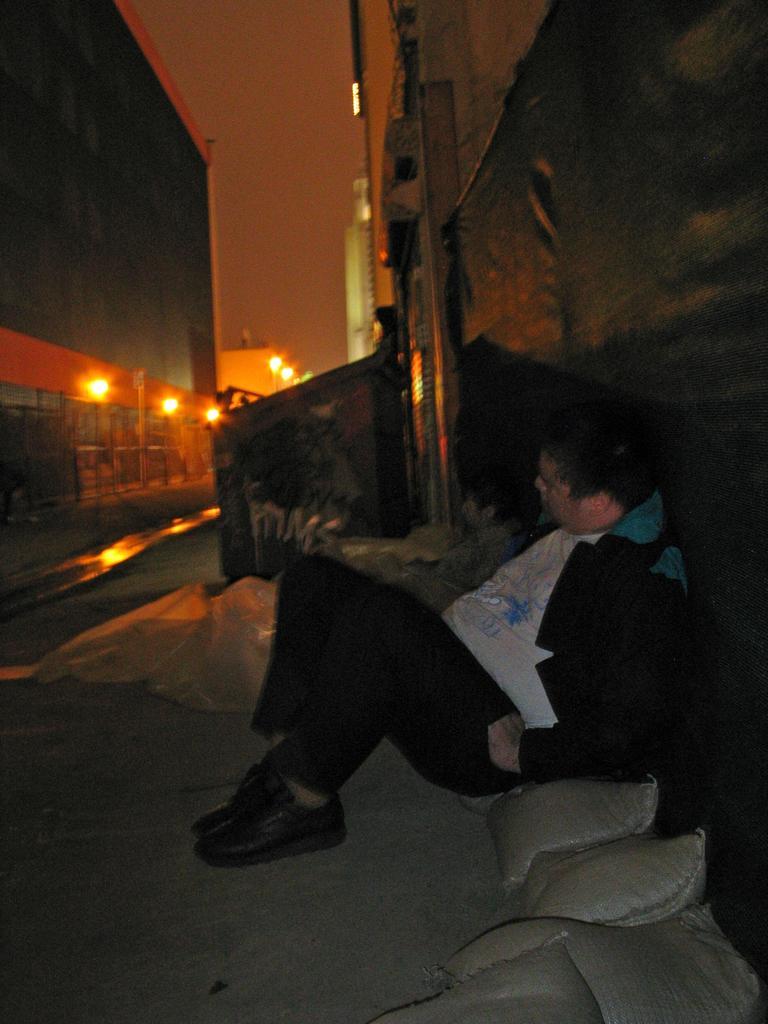In one or two sentences, can you explain what this image depicts? In this picture I can see a person sitting on the sack, there are so many sacks, there are lights, iron grilles, and there are some other items. 